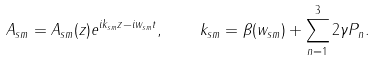Convert formula to latex. <formula><loc_0><loc_0><loc_500><loc_500>A _ { s m } = A _ { s m } ( z ) e ^ { i k _ { s m } z - i w _ { s m } t } , \quad k _ { s m } = \beta ( w _ { s m } ) + \sum _ { n = 1 } ^ { 3 } 2 \gamma P _ { n } .</formula> 